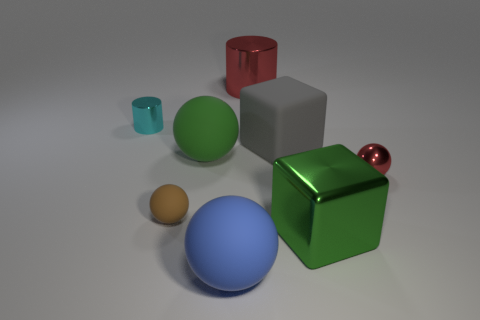There is a big cube behind the small brown rubber object; is its color the same as the tiny cylinder?
Your answer should be compact. No. There is a large object that is both behind the small brown rubber object and right of the red metallic cylinder; what material is it?
Make the answer very short. Rubber. Is there a red metallic cube that has the same size as the metal sphere?
Give a very brief answer. No. What number of big matte blocks are there?
Make the answer very short. 1. There is a big gray rubber thing; how many metal cylinders are in front of it?
Offer a very short reply. 0. Does the blue thing have the same material as the small red sphere?
Offer a terse response. No. What number of large things are in front of the gray rubber thing and behind the large green block?
Provide a short and direct response. 1. How many other things are there of the same color as the tiny shiny cylinder?
Your response must be concise. 0. What number of purple things are either shiny spheres or tiny metal cylinders?
Give a very brief answer. 0. What size is the matte cube?
Your answer should be very brief. Large. 